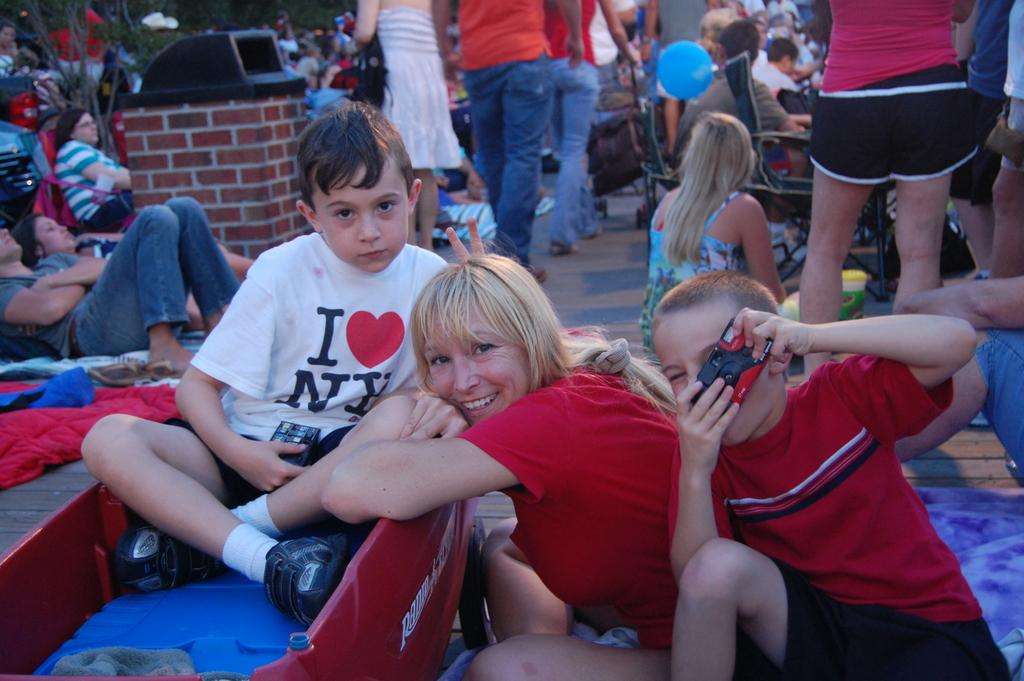What is the main feature of the image? There is a huge crowd in the image. What might be the reason for the crowd being present? It appears that an event is taking place in the area. Can you describe any structures or objects in the image? There is a small brick wall in the image, and an object is placed on it. What type of horn can be heard during the event in the image? There is no audible sound in the image, so it is impossible to determine if a horn is being used or heard. 